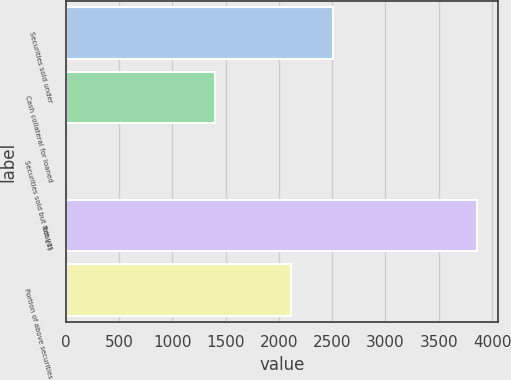<chart> <loc_0><loc_0><loc_500><loc_500><bar_chart><fcel>Securities sold under<fcel>Cash collateral for loaned<fcel>Securities sold but not yet<fcel>Total(1)<fcel>Portion of above securities<nl><fcel>2503.16<fcel>1401<fcel>0.42<fcel>3862<fcel>2117<nl></chart> 